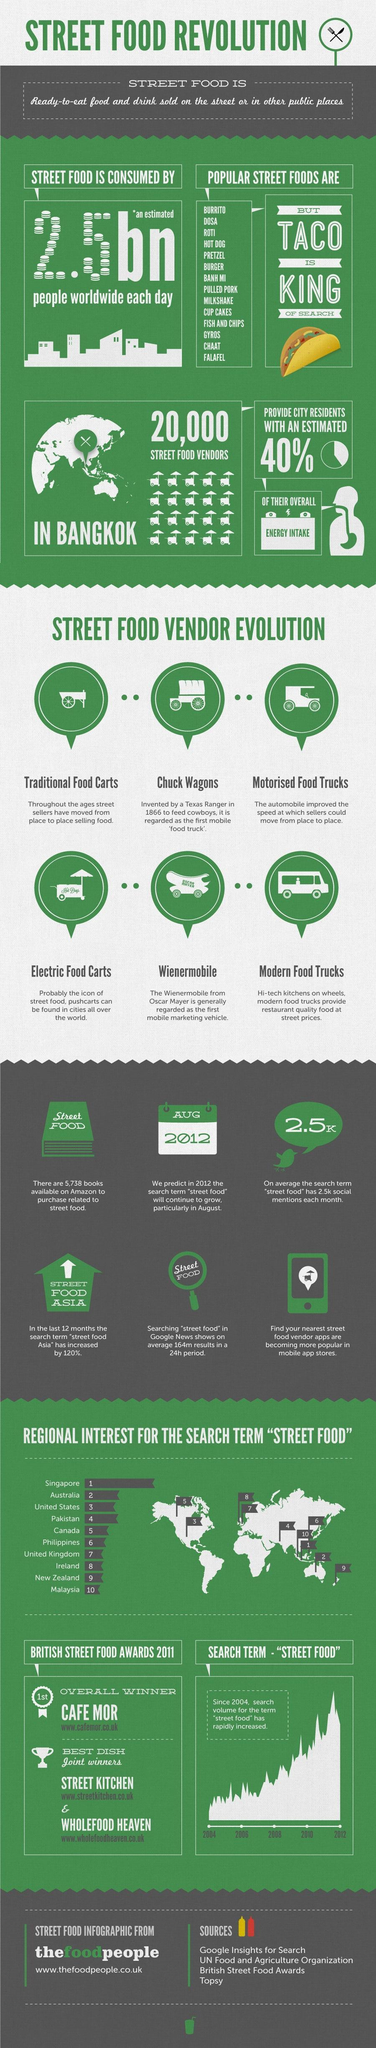In which year has the search term "street food" increased?
Answer the question with a short phrase. 2012 